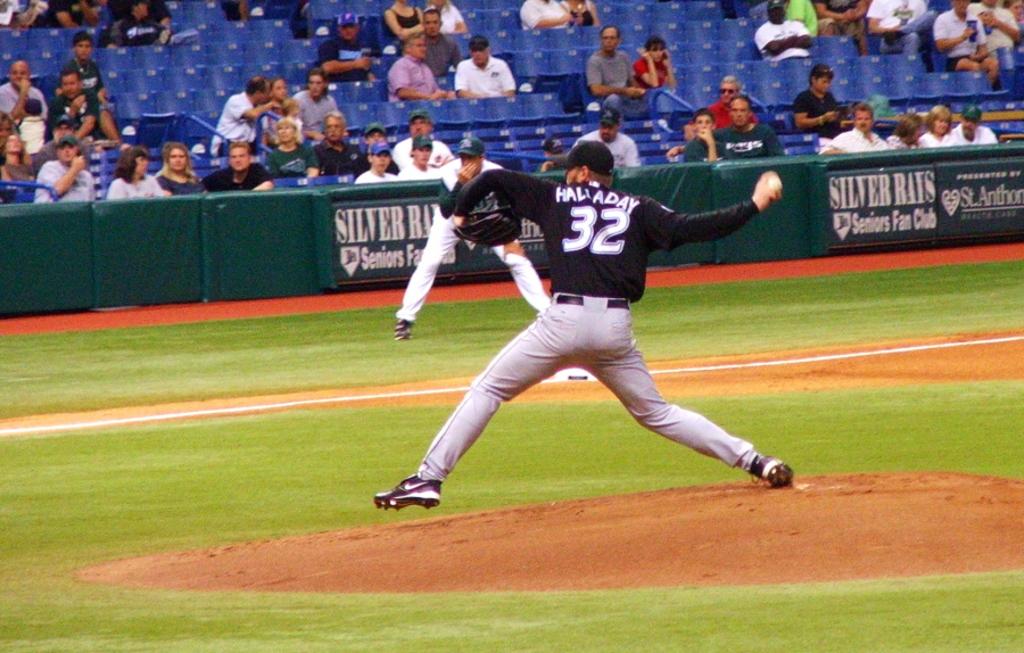What player is pitching the ball?
Offer a terse response. 32. What number is he?
Make the answer very short. 32. 